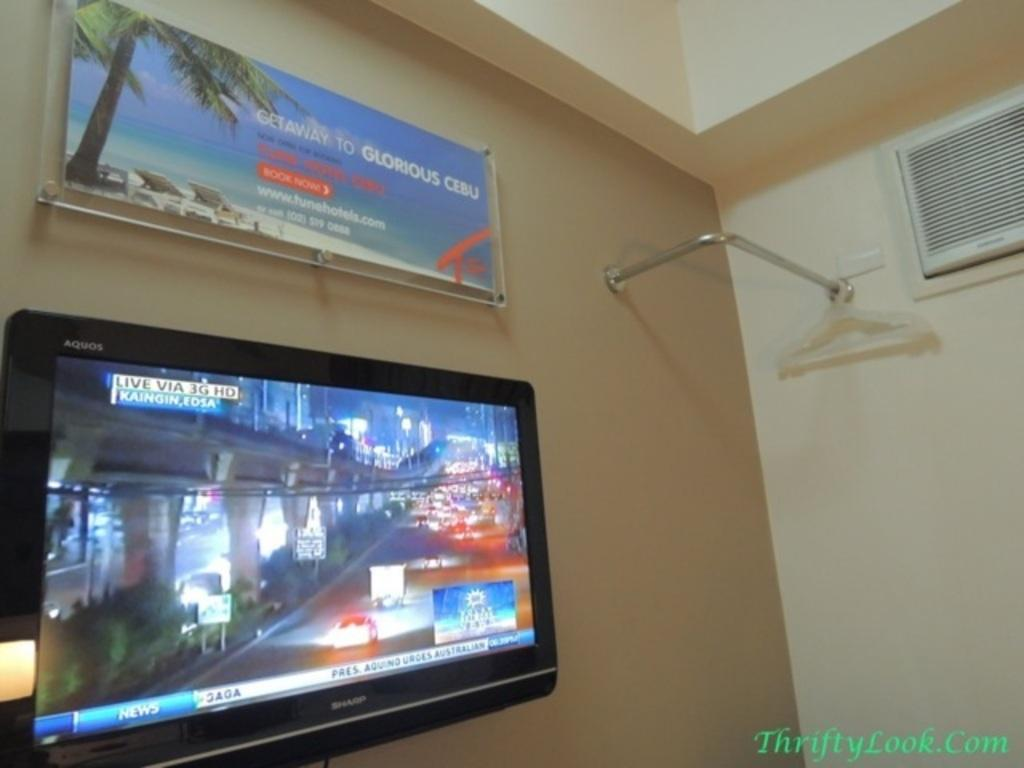<image>
Render a clear and concise summary of the photo. An advertisement for Cebu is situated above a wall mounted TV. 